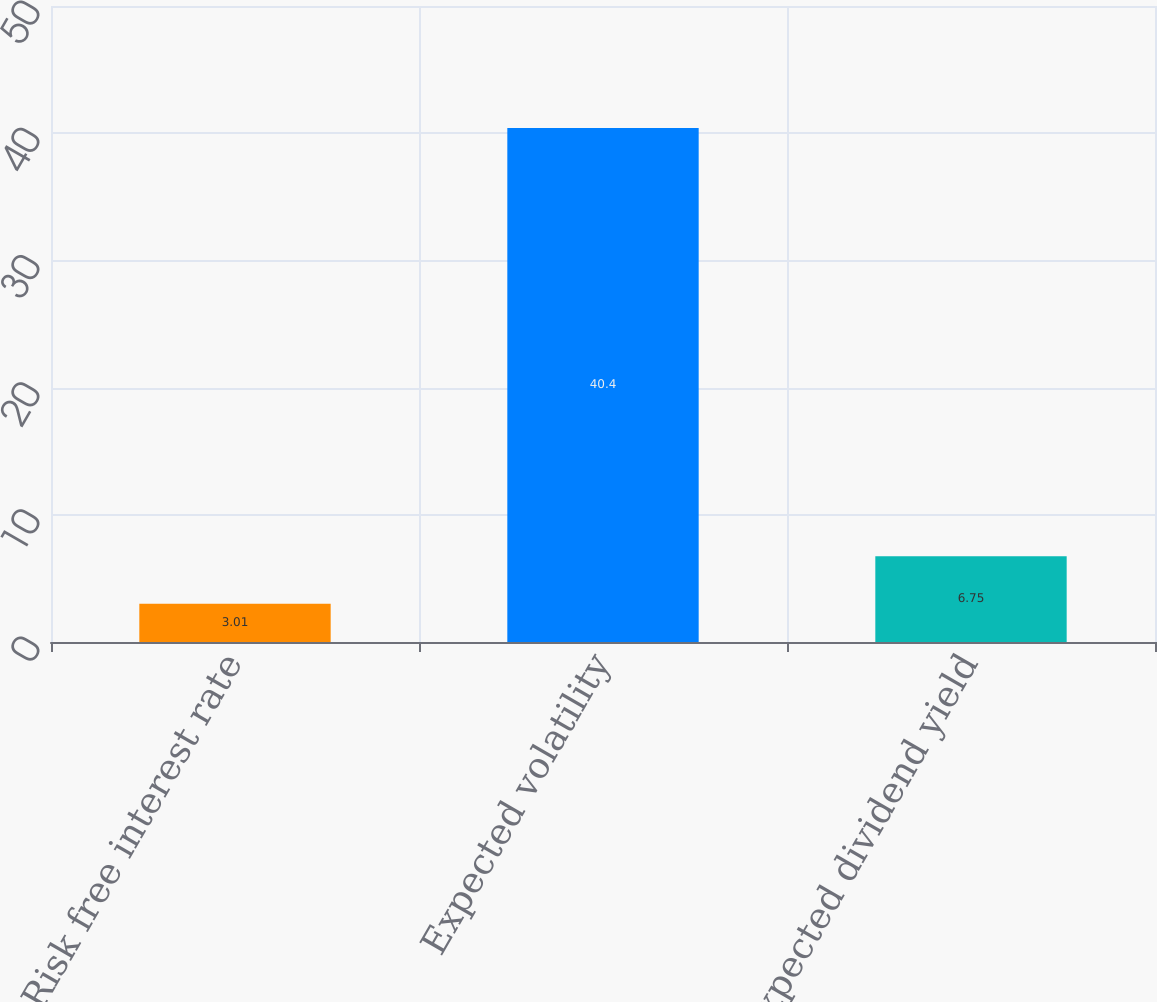Convert chart. <chart><loc_0><loc_0><loc_500><loc_500><bar_chart><fcel>Risk free interest rate<fcel>Expected volatility<fcel>Expected dividend yield<nl><fcel>3.01<fcel>40.4<fcel>6.75<nl></chart> 